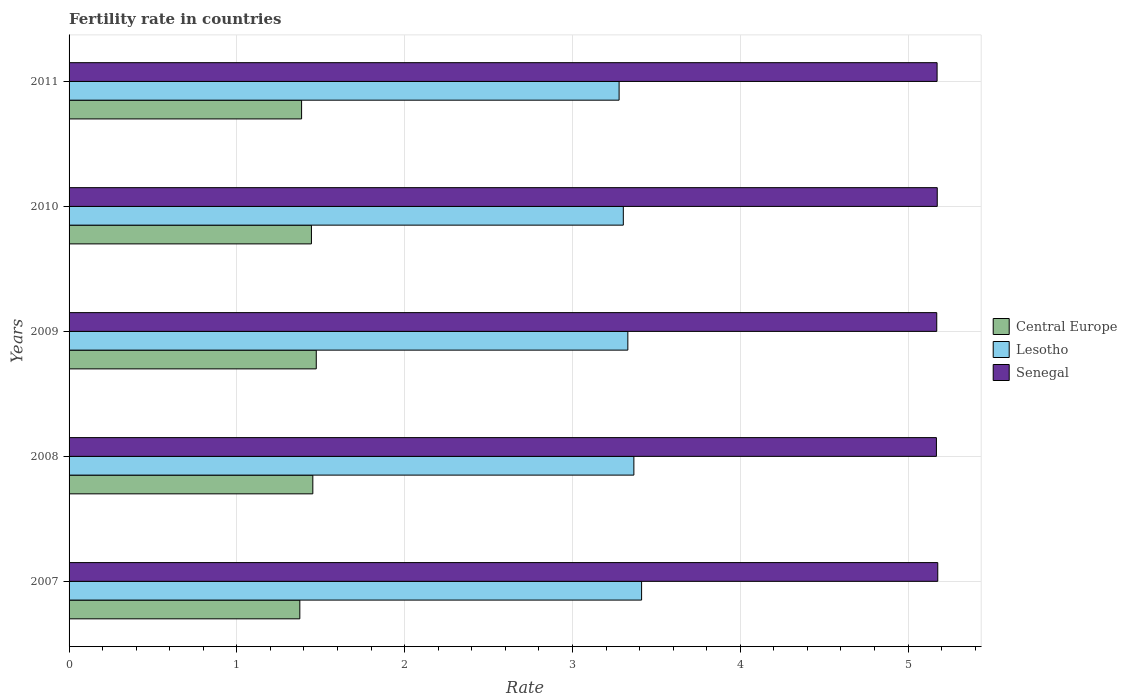How many different coloured bars are there?
Provide a short and direct response. 3. How many groups of bars are there?
Give a very brief answer. 5. Are the number of bars per tick equal to the number of legend labels?
Provide a short and direct response. Yes. How many bars are there on the 3rd tick from the bottom?
Ensure brevity in your answer.  3. What is the fertility rate in Lesotho in 2007?
Give a very brief answer. 3.41. Across all years, what is the maximum fertility rate in Central Europe?
Provide a short and direct response. 1.47. Across all years, what is the minimum fertility rate in Senegal?
Give a very brief answer. 5.17. In which year was the fertility rate in Lesotho minimum?
Provide a short and direct response. 2011. What is the total fertility rate in Lesotho in the graph?
Your response must be concise. 16.69. What is the difference between the fertility rate in Lesotho in 2008 and that in 2010?
Your answer should be very brief. 0.06. What is the difference between the fertility rate in Lesotho in 2009 and the fertility rate in Senegal in 2011?
Make the answer very short. -1.84. What is the average fertility rate in Senegal per year?
Offer a terse response. 5.17. In the year 2009, what is the difference between the fertility rate in Central Europe and fertility rate in Senegal?
Give a very brief answer. -3.7. What is the ratio of the fertility rate in Central Europe in 2008 to that in 2009?
Offer a terse response. 0.99. What is the difference between the highest and the second highest fertility rate in Central Europe?
Give a very brief answer. 0.02. What is the difference between the highest and the lowest fertility rate in Senegal?
Provide a succinct answer. 0.01. What does the 1st bar from the top in 2008 represents?
Keep it short and to the point. Senegal. What does the 2nd bar from the bottom in 2011 represents?
Your answer should be compact. Lesotho. Is it the case that in every year, the sum of the fertility rate in Lesotho and fertility rate in Senegal is greater than the fertility rate in Central Europe?
Ensure brevity in your answer.  Yes. Are all the bars in the graph horizontal?
Your answer should be very brief. Yes. What is the difference between two consecutive major ticks on the X-axis?
Provide a short and direct response. 1. Are the values on the major ticks of X-axis written in scientific E-notation?
Offer a terse response. No. Does the graph contain any zero values?
Offer a very short reply. No. Does the graph contain grids?
Your response must be concise. Yes. How many legend labels are there?
Keep it short and to the point. 3. What is the title of the graph?
Ensure brevity in your answer.  Fertility rate in countries. What is the label or title of the X-axis?
Provide a short and direct response. Rate. What is the Rate in Central Europe in 2007?
Your answer should be compact. 1.38. What is the Rate in Lesotho in 2007?
Ensure brevity in your answer.  3.41. What is the Rate of Senegal in 2007?
Your answer should be compact. 5.18. What is the Rate in Central Europe in 2008?
Your response must be concise. 1.45. What is the Rate in Lesotho in 2008?
Give a very brief answer. 3.37. What is the Rate in Senegal in 2008?
Your answer should be compact. 5.17. What is the Rate in Central Europe in 2009?
Ensure brevity in your answer.  1.47. What is the Rate of Lesotho in 2009?
Ensure brevity in your answer.  3.33. What is the Rate of Senegal in 2009?
Offer a terse response. 5.17. What is the Rate of Central Europe in 2010?
Make the answer very short. 1.44. What is the Rate in Lesotho in 2010?
Provide a succinct answer. 3.3. What is the Rate in Senegal in 2010?
Give a very brief answer. 5.17. What is the Rate in Central Europe in 2011?
Keep it short and to the point. 1.39. What is the Rate in Lesotho in 2011?
Offer a terse response. 3.28. What is the Rate of Senegal in 2011?
Ensure brevity in your answer.  5.17. Across all years, what is the maximum Rate in Central Europe?
Your answer should be compact. 1.47. Across all years, what is the maximum Rate in Lesotho?
Give a very brief answer. 3.41. Across all years, what is the maximum Rate in Senegal?
Your answer should be very brief. 5.18. Across all years, what is the minimum Rate in Central Europe?
Give a very brief answer. 1.38. Across all years, what is the minimum Rate in Lesotho?
Make the answer very short. 3.28. Across all years, what is the minimum Rate of Senegal?
Your response must be concise. 5.17. What is the total Rate of Central Europe in the graph?
Keep it short and to the point. 7.13. What is the total Rate of Lesotho in the graph?
Offer a terse response. 16.69. What is the total Rate of Senegal in the graph?
Your answer should be very brief. 25.86. What is the difference between the Rate in Central Europe in 2007 and that in 2008?
Your answer should be compact. -0.08. What is the difference between the Rate of Lesotho in 2007 and that in 2008?
Give a very brief answer. 0.05. What is the difference between the Rate of Senegal in 2007 and that in 2008?
Your answer should be compact. 0.01. What is the difference between the Rate of Central Europe in 2007 and that in 2009?
Offer a terse response. -0.1. What is the difference between the Rate in Lesotho in 2007 and that in 2009?
Your answer should be very brief. 0.08. What is the difference between the Rate of Senegal in 2007 and that in 2009?
Your answer should be compact. 0.01. What is the difference between the Rate of Central Europe in 2007 and that in 2010?
Keep it short and to the point. -0.07. What is the difference between the Rate of Lesotho in 2007 and that in 2010?
Your answer should be compact. 0.11. What is the difference between the Rate in Senegal in 2007 and that in 2010?
Ensure brevity in your answer.  0. What is the difference between the Rate in Central Europe in 2007 and that in 2011?
Provide a succinct answer. -0.01. What is the difference between the Rate in Lesotho in 2007 and that in 2011?
Give a very brief answer. 0.13. What is the difference between the Rate in Senegal in 2007 and that in 2011?
Offer a very short reply. 0. What is the difference between the Rate in Central Europe in 2008 and that in 2009?
Your answer should be compact. -0.02. What is the difference between the Rate of Lesotho in 2008 and that in 2009?
Offer a very short reply. 0.04. What is the difference between the Rate in Senegal in 2008 and that in 2009?
Your answer should be very brief. -0. What is the difference between the Rate in Central Europe in 2008 and that in 2010?
Offer a terse response. 0.01. What is the difference between the Rate of Lesotho in 2008 and that in 2010?
Ensure brevity in your answer.  0.06. What is the difference between the Rate of Senegal in 2008 and that in 2010?
Keep it short and to the point. -0.01. What is the difference between the Rate of Central Europe in 2008 and that in 2011?
Offer a very short reply. 0.07. What is the difference between the Rate of Lesotho in 2008 and that in 2011?
Your answer should be compact. 0.09. What is the difference between the Rate in Senegal in 2008 and that in 2011?
Provide a succinct answer. -0. What is the difference between the Rate in Central Europe in 2009 and that in 2010?
Your response must be concise. 0.03. What is the difference between the Rate in Lesotho in 2009 and that in 2010?
Your response must be concise. 0.03. What is the difference between the Rate of Senegal in 2009 and that in 2010?
Keep it short and to the point. -0. What is the difference between the Rate in Central Europe in 2009 and that in 2011?
Offer a very short reply. 0.09. What is the difference between the Rate in Lesotho in 2009 and that in 2011?
Offer a terse response. 0.05. What is the difference between the Rate in Senegal in 2009 and that in 2011?
Your answer should be very brief. -0. What is the difference between the Rate of Central Europe in 2010 and that in 2011?
Your answer should be compact. 0.06. What is the difference between the Rate in Lesotho in 2010 and that in 2011?
Your response must be concise. 0.03. What is the difference between the Rate of Senegal in 2010 and that in 2011?
Provide a short and direct response. 0. What is the difference between the Rate in Central Europe in 2007 and the Rate in Lesotho in 2008?
Make the answer very short. -1.99. What is the difference between the Rate in Central Europe in 2007 and the Rate in Senegal in 2008?
Offer a very short reply. -3.79. What is the difference between the Rate of Lesotho in 2007 and the Rate of Senegal in 2008?
Give a very brief answer. -1.76. What is the difference between the Rate in Central Europe in 2007 and the Rate in Lesotho in 2009?
Provide a short and direct response. -1.95. What is the difference between the Rate of Central Europe in 2007 and the Rate of Senegal in 2009?
Keep it short and to the point. -3.8. What is the difference between the Rate of Lesotho in 2007 and the Rate of Senegal in 2009?
Your answer should be compact. -1.76. What is the difference between the Rate in Central Europe in 2007 and the Rate in Lesotho in 2010?
Offer a very short reply. -1.93. What is the difference between the Rate in Central Europe in 2007 and the Rate in Senegal in 2010?
Make the answer very short. -3.8. What is the difference between the Rate of Lesotho in 2007 and the Rate of Senegal in 2010?
Your answer should be compact. -1.76. What is the difference between the Rate of Central Europe in 2007 and the Rate of Lesotho in 2011?
Keep it short and to the point. -1.9. What is the difference between the Rate in Central Europe in 2007 and the Rate in Senegal in 2011?
Offer a very short reply. -3.8. What is the difference between the Rate of Lesotho in 2007 and the Rate of Senegal in 2011?
Offer a terse response. -1.76. What is the difference between the Rate of Central Europe in 2008 and the Rate of Lesotho in 2009?
Your answer should be very brief. -1.88. What is the difference between the Rate of Central Europe in 2008 and the Rate of Senegal in 2009?
Offer a very short reply. -3.72. What is the difference between the Rate of Lesotho in 2008 and the Rate of Senegal in 2009?
Your answer should be compact. -1.8. What is the difference between the Rate in Central Europe in 2008 and the Rate in Lesotho in 2010?
Ensure brevity in your answer.  -1.85. What is the difference between the Rate of Central Europe in 2008 and the Rate of Senegal in 2010?
Give a very brief answer. -3.72. What is the difference between the Rate in Lesotho in 2008 and the Rate in Senegal in 2010?
Give a very brief answer. -1.81. What is the difference between the Rate in Central Europe in 2008 and the Rate in Lesotho in 2011?
Give a very brief answer. -1.83. What is the difference between the Rate in Central Europe in 2008 and the Rate in Senegal in 2011?
Make the answer very short. -3.72. What is the difference between the Rate in Lesotho in 2008 and the Rate in Senegal in 2011?
Ensure brevity in your answer.  -1.81. What is the difference between the Rate of Central Europe in 2009 and the Rate of Lesotho in 2010?
Provide a short and direct response. -1.83. What is the difference between the Rate of Central Europe in 2009 and the Rate of Senegal in 2010?
Offer a very short reply. -3.7. What is the difference between the Rate of Lesotho in 2009 and the Rate of Senegal in 2010?
Offer a terse response. -1.84. What is the difference between the Rate of Central Europe in 2009 and the Rate of Lesotho in 2011?
Provide a short and direct response. -1.8. What is the difference between the Rate in Central Europe in 2009 and the Rate in Senegal in 2011?
Ensure brevity in your answer.  -3.7. What is the difference between the Rate in Lesotho in 2009 and the Rate in Senegal in 2011?
Keep it short and to the point. -1.84. What is the difference between the Rate of Central Europe in 2010 and the Rate of Lesotho in 2011?
Offer a terse response. -1.83. What is the difference between the Rate in Central Europe in 2010 and the Rate in Senegal in 2011?
Make the answer very short. -3.73. What is the difference between the Rate in Lesotho in 2010 and the Rate in Senegal in 2011?
Offer a terse response. -1.87. What is the average Rate of Central Europe per year?
Provide a short and direct response. 1.43. What is the average Rate of Lesotho per year?
Your answer should be very brief. 3.34. What is the average Rate in Senegal per year?
Your answer should be compact. 5.17. In the year 2007, what is the difference between the Rate of Central Europe and Rate of Lesotho?
Provide a short and direct response. -2.04. In the year 2007, what is the difference between the Rate of Central Europe and Rate of Senegal?
Your answer should be very brief. -3.8. In the year 2007, what is the difference between the Rate in Lesotho and Rate in Senegal?
Make the answer very short. -1.76. In the year 2008, what is the difference between the Rate in Central Europe and Rate in Lesotho?
Your answer should be compact. -1.91. In the year 2008, what is the difference between the Rate of Central Europe and Rate of Senegal?
Your response must be concise. -3.72. In the year 2008, what is the difference between the Rate in Lesotho and Rate in Senegal?
Offer a very short reply. -1.8. In the year 2009, what is the difference between the Rate in Central Europe and Rate in Lesotho?
Offer a very short reply. -1.86. In the year 2009, what is the difference between the Rate in Central Europe and Rate in Senegal?
Provide a succinct answer. -3.7. In the year 2009, what is the difference between the Rate of Lesotho and Rate of Senegal?
Offer a terse response. -1.84. In the year 2010, what is the difference between the Rate of Central Europe and Rate of Lesotho?
Offer a very short reply. -1.86. In the year 2010, what is the difference between the Rate of Central Europe and Rate of Senegal?
Your answer should be very brief. -3.73. In the year 2010, what is the difference between the Rate in Lesotho and Rate in Senegal?
Ensure brevity in your answer.  -1.87. In the year 2011, what is the difference between the Rate of Central Europe and Rate of Lesotho?
Your response must be concise. -1.89. In the year 2011, what is the difference between the Rate of Central Europe and Rate of Senegal?
Provide a succinct answer. -3.79. In the year 2011, what is the difference between the Rate in Lesotho and Rate in Senegal?
Your answer should be compact. -1.9. What is the ratio of the Rate in Central Europe in 2007 to that in 2008?
Provide a succinct answer. 0.95. What is the ratio of the Rate of Lesotho in 2007 to that in 2008?
Provide a short and direct response. 1.01. What is the ratio of the Rate of Central Europe in 2007 to that in 2009?
Your response must be concise. 0.93. What is the ratio of the Rate in Lesotho in 2007 to that in 2009?
Keep it short and to the point. 1.02. What is the ratio of the Rate of Senegal in 2007 to that in 2009?
Offer a terse response. 1. What is the ratio of the Rate in Central Europe in 2007 to that in 2010?
Give a very brief answer. 0.95. What is the ratio of the Rate in Lesotho in 2007 to that in 2010?
Provide a succinct answer. 1.03. What is the ratio of the Rate in Senegal in 2007 to that in 2010?
Your answer should be very brief. 1. What is the ratio of the Rate of Central Europe in 2007 to that in 2011?
Ensure brevity in your answer.  0.99. What is the ratio of the Rate in Lesotho in 2007 to that in 2011?
Ensure brevity in your answer.  1.04. What is the ratio of the Rate in Central Europe in 2008 to that in 2009?
Your answer should be very brief. 0.99. What is the ratio of the Rate of Lesotho in 2008 to that in 2009?
Ensure brevity in your answer.  1.01. What is the ratio of the Rate of Lesotho in 2008 to that in 2010?
Your response must be concise. 1.02. What is the ratio of the Rate in Central Europe in 2008 to that in 2011?
Provide a short and direct response. 1.05. What is the ratio of the Rate of Lesotho in 2008 to that in 2011?
Offer a very short reply. 1.03. What is the ratio of the Rate of Senegal in 2008 to that in 2011?
Your answer should be compact. 1. What is the ratio of the Rate of Central Europe in 2009 to that in 2010?
Offer a very short reply. 1.02. What is the ratio of the Rate of Lesotho in 2009 to that in 2010?
Your response must be concise. 1.01. What is the ratio of the Rate of Central Europe in 2009 to that in 2011?
Ensure brevity in your answer.  1.06. What is the ratio of the Rate of Lesotho in 2009 to that in 2011?
Offer a very short reply. 1.02. What is the ratio of the Rate in Central Europe in 2010 to that in 2011?
Provide a short and direct response. 1.04. What is the ratio of the Rate of Lesotho in 2010 to that in 2011?
Ensure brevity in your answer.  1.01. What is the difference between the highest and the second highest Rate in Central Europe?
Keep it short and to the point. 0.02. What is the difference between the highest and the second highest Rate in Lesotho?
Provide a short and direct response. 0.05. What is the difference between the highest and the second highest Rate of Senegal?
Make the answer very short. 0. What is the difference between the highest and the lowest Rate of Central Europe?
Provide a succinct answer. 0.1. What is the difference between the highest and the lowest Rate in Lesotho?
Your response must be concise. 0.13. What is the difference between the highest and the lowest Rate in Senegal?
Your response must be concise. 0.01. 